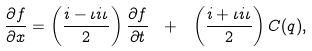<formula> <loc_0><loc_0><loc_500><loc_500>\frac { \partial f } { \partial x } = \left ( \frac { i - \iota i \iota } { 2 } \right ) \frac { \partial f } { \partial t } \ + \ \left ( \frac { i + \iota i \iota } { 2 } \right ) C ( q ) ,</formula> 